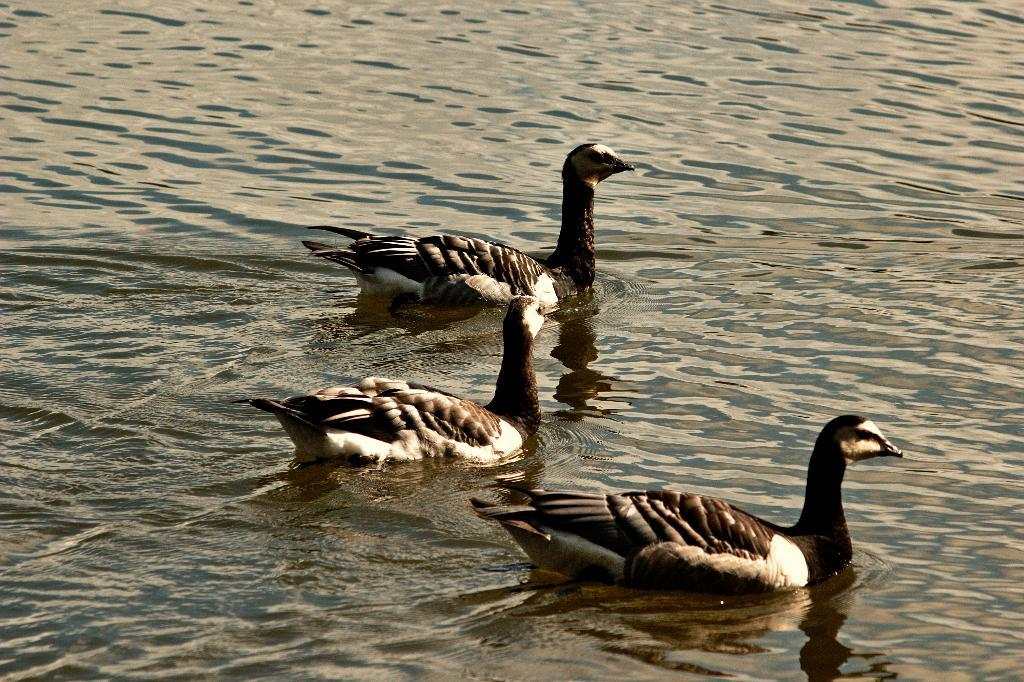What type of animals can be seen in the image? Birds can be seen in the image. What is the primary element in which the birds are situated? The birds are situated in water. What type of branch can be seen in the image? There is no branch present in the image; it features birds in the water. What are the birds talking about in the image? Birds do not have the ability to talk, so there is no conversation to be observed in the image. 